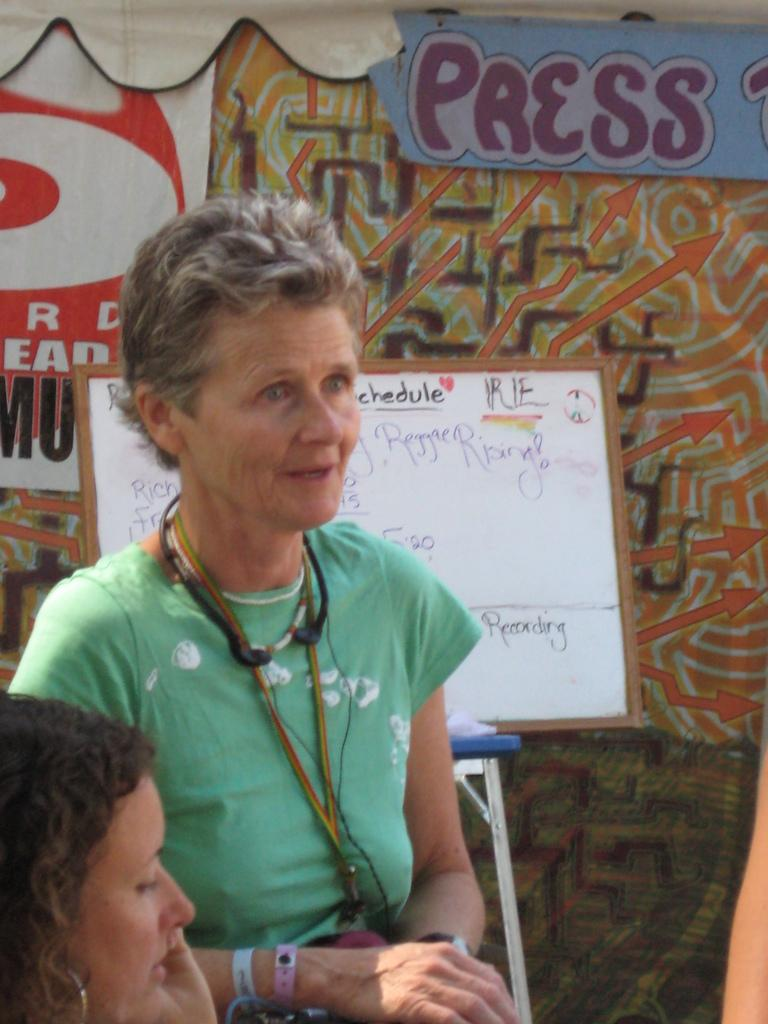Who can be seen on the left side of the image? There are two ladies on the left side of the image. What is located in the center of the image? A board and a stand are present in the center of the image. What can be seen in the background of the image? There is a tent in the background of the image. What type of bottle is being used by the ladies in the image? There is no bottle present in the image; the ladies are not holding or using any bottles. 